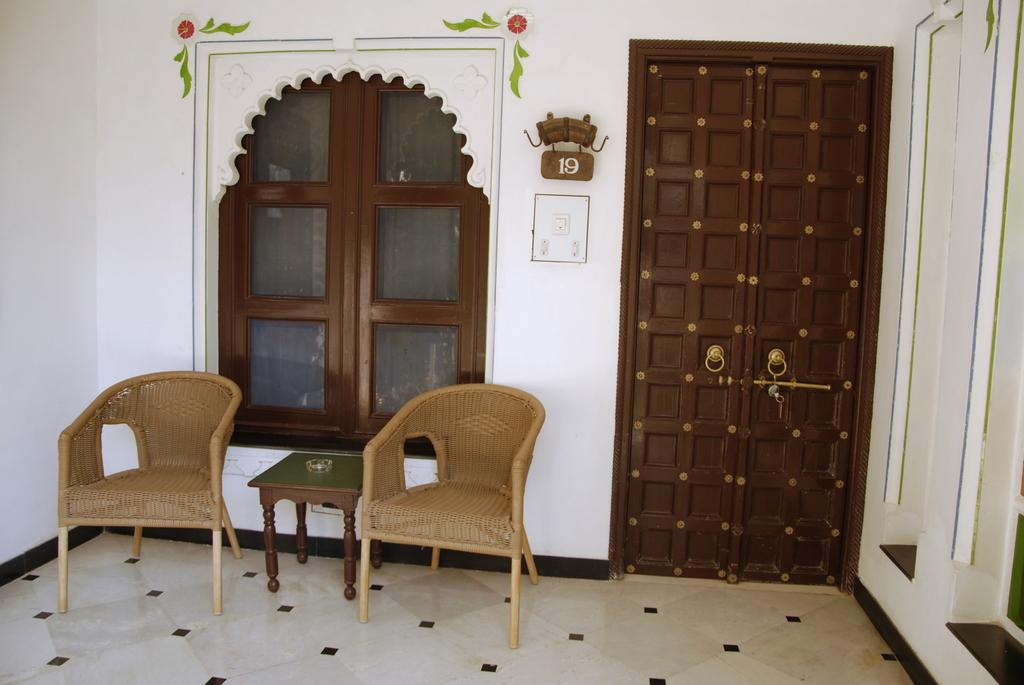What type of furniture is located on the left side of the image? There are chairs and a table on the left side of the image. What feature of the room can be used for entering or exiting? There is a door in the image. What allows natural light to enter the room in the image? There are glass windows in the image. Can you tell me how many lawyers are visible in the image? There are no lawyers present in the image. What type of badge is hanging from the door in the image? There is no badge visible in the image. 